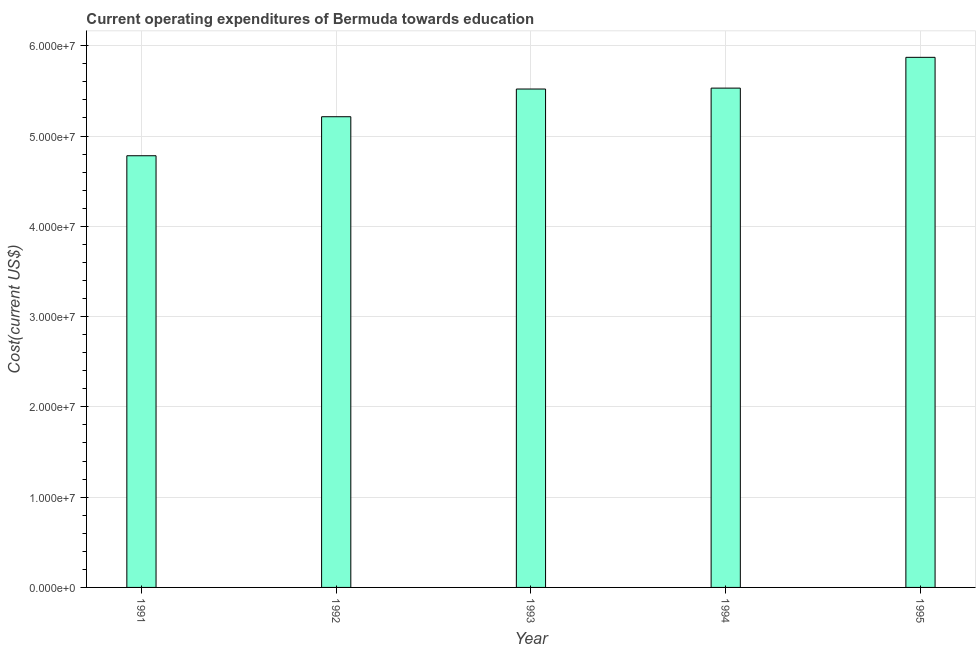Does the graph contain any zero values?
Ensure brevity in your answer.  No. Does the graph contain grids?
Offer a very short reply. Yes. What is the title of the graph?
Your answer should be very brief. Current operating expenditures of Bermuda towards education. What is the label or title of the X-axis?
Offer a terse response. Year. What is the label or title of the Y-axis?
Provide a succinct answer. Cost(current US$). What is the education expenditure in 1991?
Provide a succinct answer. 4.78e+07. Across all years, what is the maximum education expenditure?
Your answer should be very brief. 5.87e+07. Across all years, what is the minimum education expenditure?
Provide a succinct answer. 4.78e+07. What is the sum of the education expenditure?
Offer a terse response. 2.69e+08. What is the difference between the education expenditure in 1991 and 1992?
Offer a terse response. -4.32e+06. What is the average education expenditure per year?
Provide a succinct answer. 5.38e+07. What is the median education expenditure?
Give a very brief answer. 5.52e+07. What is the ratio of the education expenditure in 1994 to that in 1995?
Provide a short and direct response. 0.94. What is the difference between the highest and the second highest education expenditure?
Provide a succinct answer. 3.41e+06. Is the sum of the education expenditure in 1993 and 1994 greater than the maximum education expenditure across all years?
Provide a succinct answer. Yes. What is the difference between the highest and the lowest education expenditure?
Provide a succinct answer. 1.09e+07. How many bars are there?
Provide a short and direct response. 5. Are all the bars in the graph horizontal?
Offer a very short reply. No. How many years are there in the graph?
Your answer should be very brief. 5. What is the Cost(current US$) of 1991?
Your response must be concise. 4.78e+07. What is the Cost(current US$) of 1992?
Your response must be concise. 5.21e+07. What is the Cost(current US$) in 1993?
Provide a short and direct response. 5.52e+07. What is the Cost(current US$) in 1994?
Give a very brief answer. 5.53e+07. What is the Cost(current US$) of 1995?
Offer a terse response. 5.87e+07. What is the difference between the Cost(current US$) in 1991 and 1992?
Offer a very short reply. -4.32e+06. What is the difference between the Cost(current US$) in 1991 and 1993?
Make the answer very short. -7.39e+06. What is the difference between the Cost(current US$) in 1991 and 1994?
Provide a short and direct response. -7.49e+06. What is the difference between the Cost(current US$) in 1991 and 1995?
Make the answer very short. -1.09e+07. What is the difference between the Cost(current US$) in 1992 and 1993?
Make the answer very short. -3.07e+06. What is the difference between the Cost(current US$) in 1992 and 1994?
Offer a terse response. -3.17e+06. What is the difference between the Cost(current US$) in 1992 and 1995?
Keep it short and to the point. -6.58e+06. What is the difference between the Cost(current US$) in 1993 and 1994?
Keep it short and to the point. -9.98e+04. What is the difference between the Cost(current US$) in 1993 and 1995?
Ensure brevity in your answer.  -3.51e+06. What is the difference between the Cost(current US$) in 1994 and 1995?
Your response must be concise. -3.41e+06. What is the ratio of the Cost(current US$) in 1991 to that in 1992?
Provide a short and direct response. 0.92. What is the ratio of the Cost(current US$) in 1991 to that in 1993?
Provide a succinct answer. 0.87. What is the ratio of the Cost(current US$) in 1991 to that in 1994?
Keep it short and to the point. 0.86. What is the ratio of the Cost(current US$) in 1991 to that in 1995?
Make the answer very short. 0.81. What is the ratio of the Cost(current US$) in 1992 to that in 1993?
Your answer should be very brief. 0.94. What is the ratio of the Cost(current US$) in 1992 to that in 1994?
Your response must be concise. 0.94. What is the ratio of the Cost(current US$) in 1992 to that in 1995?
Give a very brief answer. 0.89. What is the ratio of the Cost(current US$) in 1993 to that in 1994?
Offer a terse response. 1. What is the ratio of the Cost(current US$) in 1993 to that in 1995?
Keep it short and to the point. 0.94. What is the ratio of the Cost(current US$) in 1994 to that in 1995?
Your answer should be very brief. 0.94. 